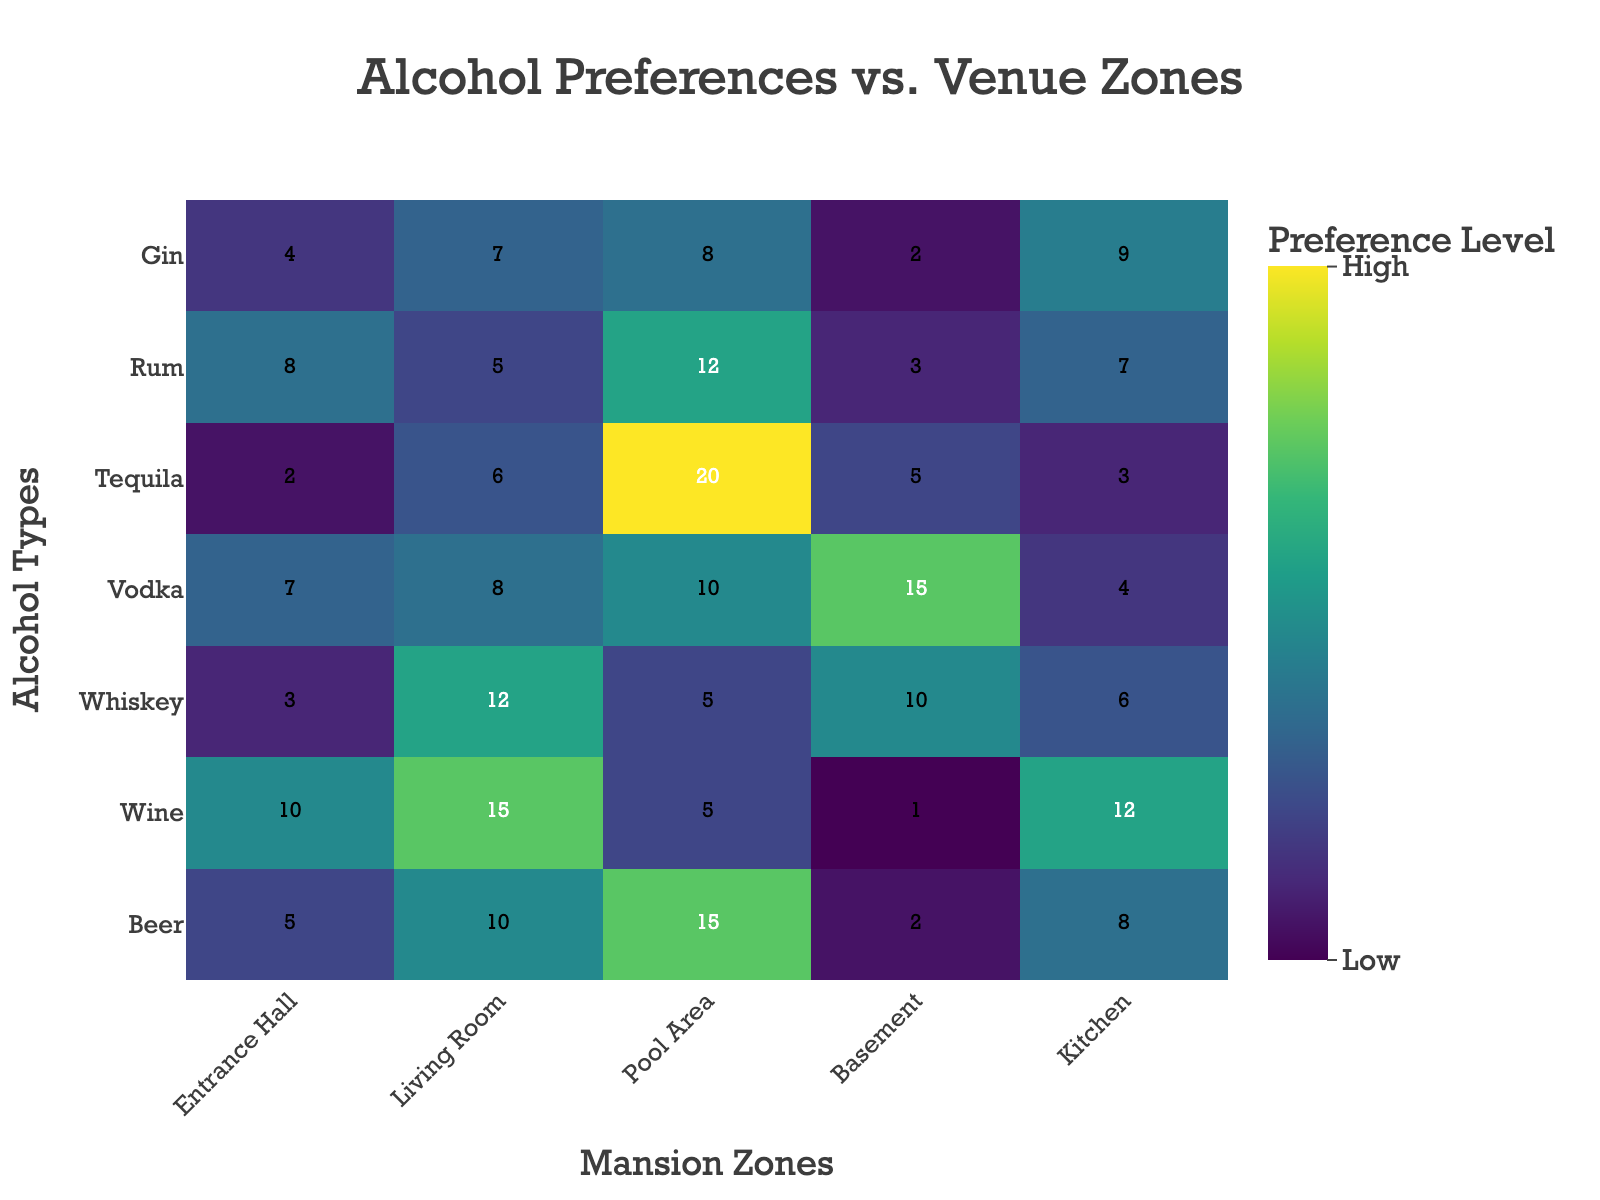Which alcohol type is most preferred in the Pool Area? Look for the highest preference level in the Pool Area column. Tequila has a value of 20, which is the highest.
Answer: Tequila What is the total preference level of Beer across all zones? Sum up the values for Beer across all the columns: 5 (Entrance Hall) + 10 (Living Room) + 15 (Pool Area) + 2 (Basement) + 8 (Kitchen) = 40.
Answer: 40 Which zone has the highest preference level for Vodka? Look for the highest value in the Vodka row across all zones. The Pool Area has a value of 15.
Answer: Pool Area What is the average preference level for Whiskey across all zones? Sum up the values for Whiskey and then divide by the number of zones: (3 + 12 + 5 + 10 + 6)/5 = 36/5 = 7.2.
Answer: 7.2 Which zone has the least preference for Wine? Look for the smallest value in the Wine row across all zones. The Basement has a value of 1.
Answer: Basement How does the preference for Beer in the Kitchen compare to the preference for Wine in the Entrance Hall? The preference for Beer in the Kitchen is 8 and for Wine in the Entrance Hall is 10. 8 < 10.
Answer: Beer in Kitchen is less preferred than Wine in Entrance Hall What are the two zones with the highest preference level for Gin? Look for the two highest values in the Gin row. Kitchen (9) and Living Room (7) have the highest values.
Answer: Kitchen, Living Room Which alcohol type has the most even distribution of preferences across all zones? Examine the rows for the smallest variance in values across the zones. Beer has values (5, 10, 15, 2, 8), while Rum has values (8, 5, 12, 3, 7). Rum shows a relatively even distribution.
Answer: Rum In which zone is Tequila less popular than Gin? Compare the values of Tequila and Gin across each zone. The Entrance Hall and Living Room have lower Tequila values compared to Gin.
Answer: Entrance Hall, Living Room 